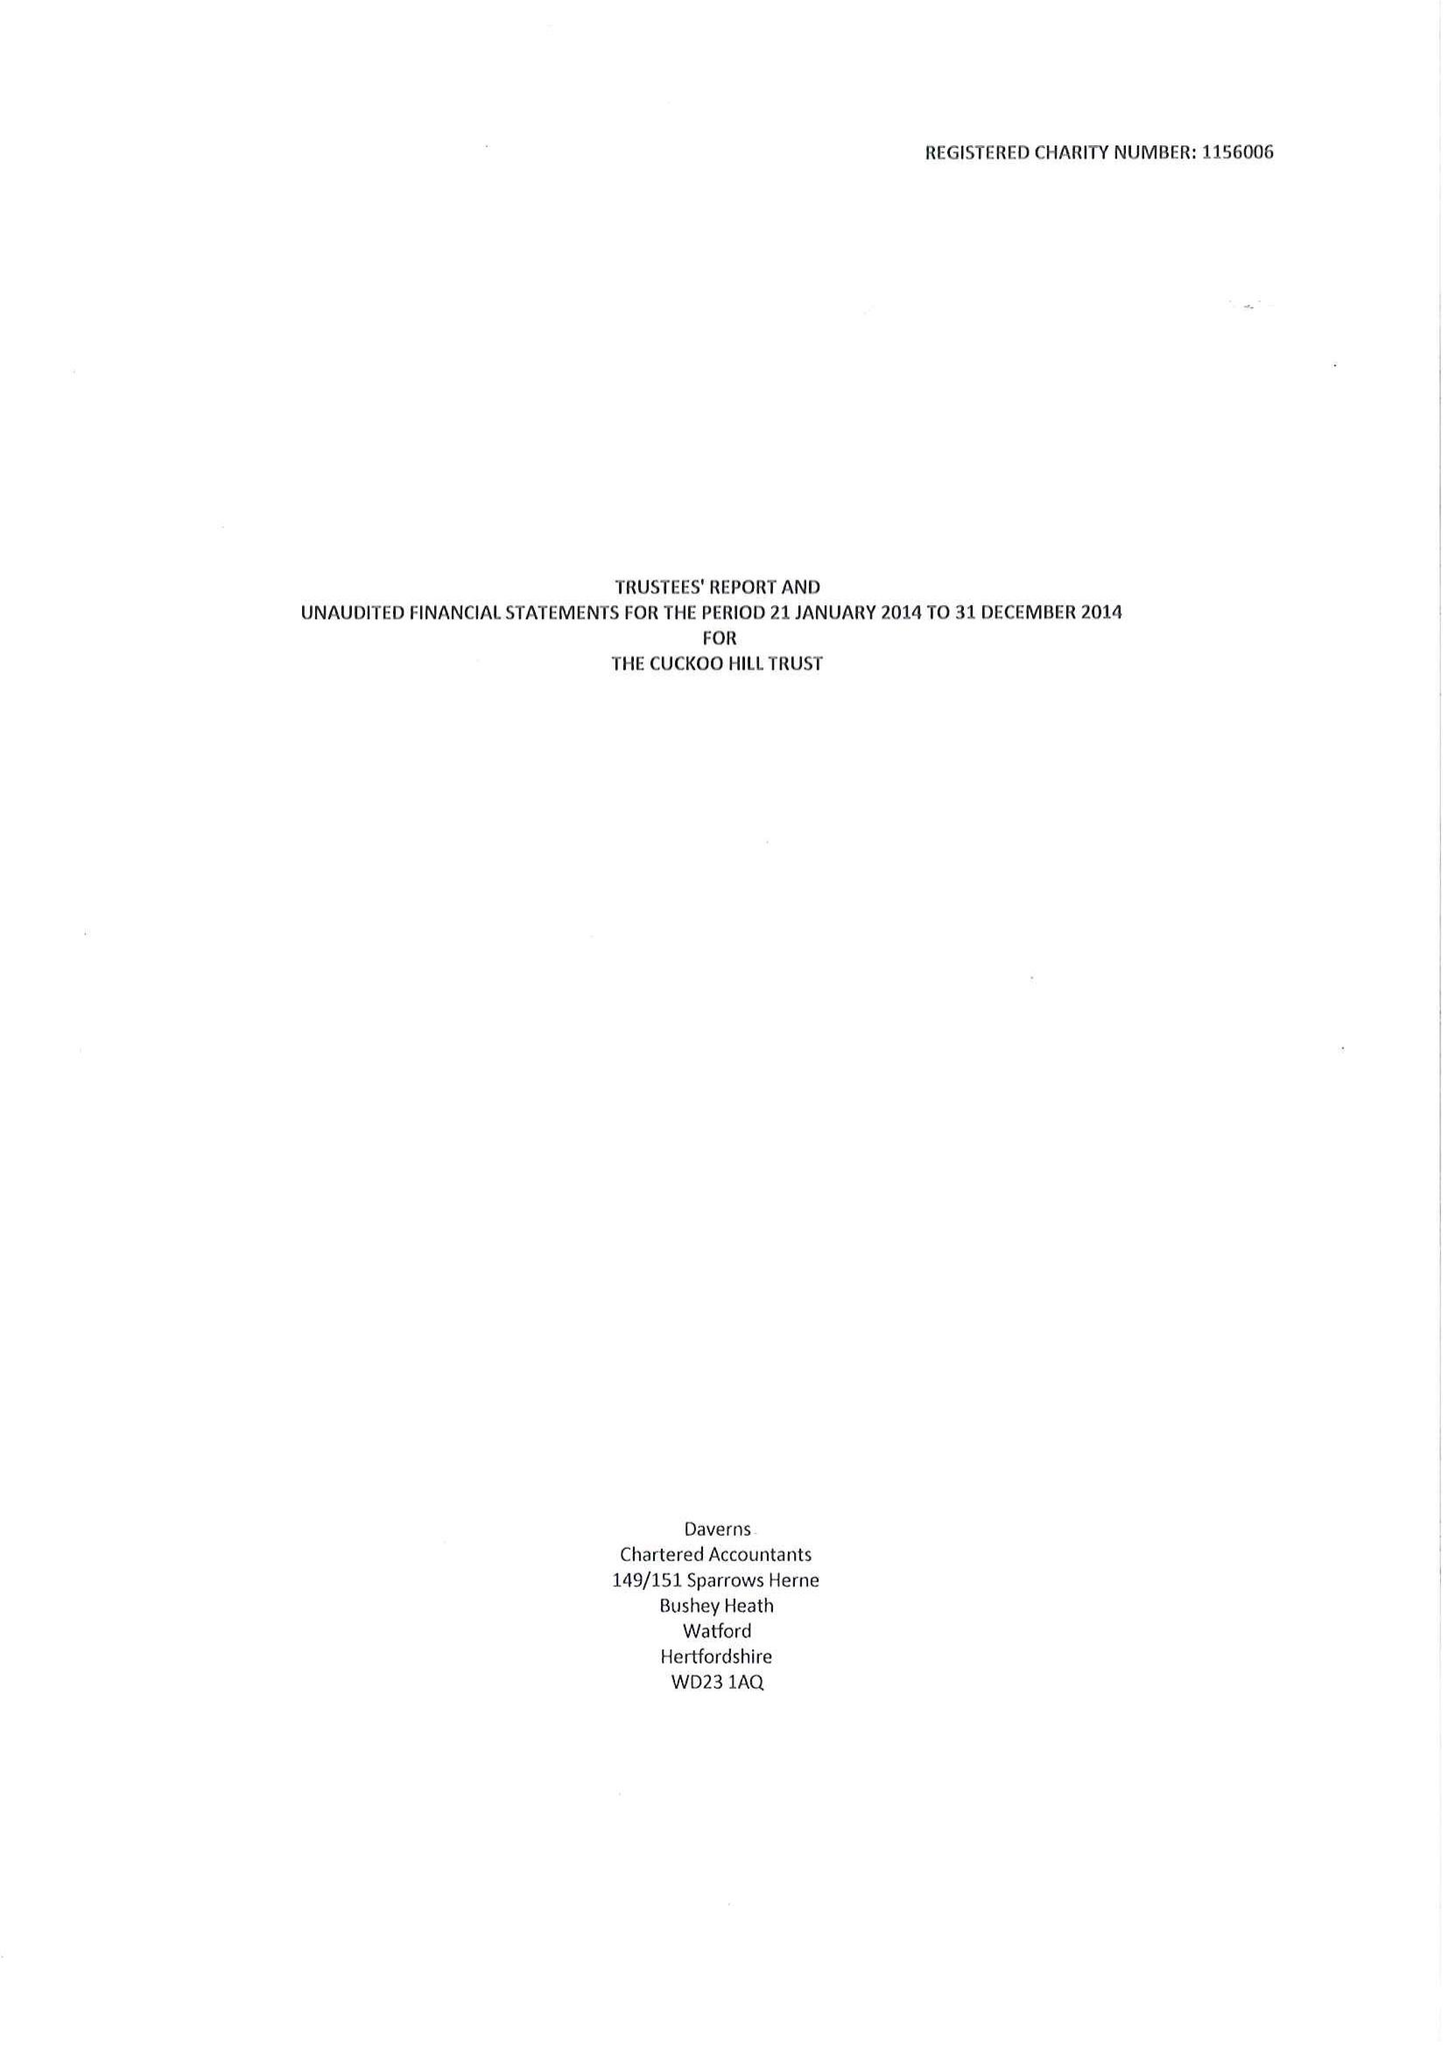What is the value for the charity_number?
Answer the question using a single word or phrase. 1156006 